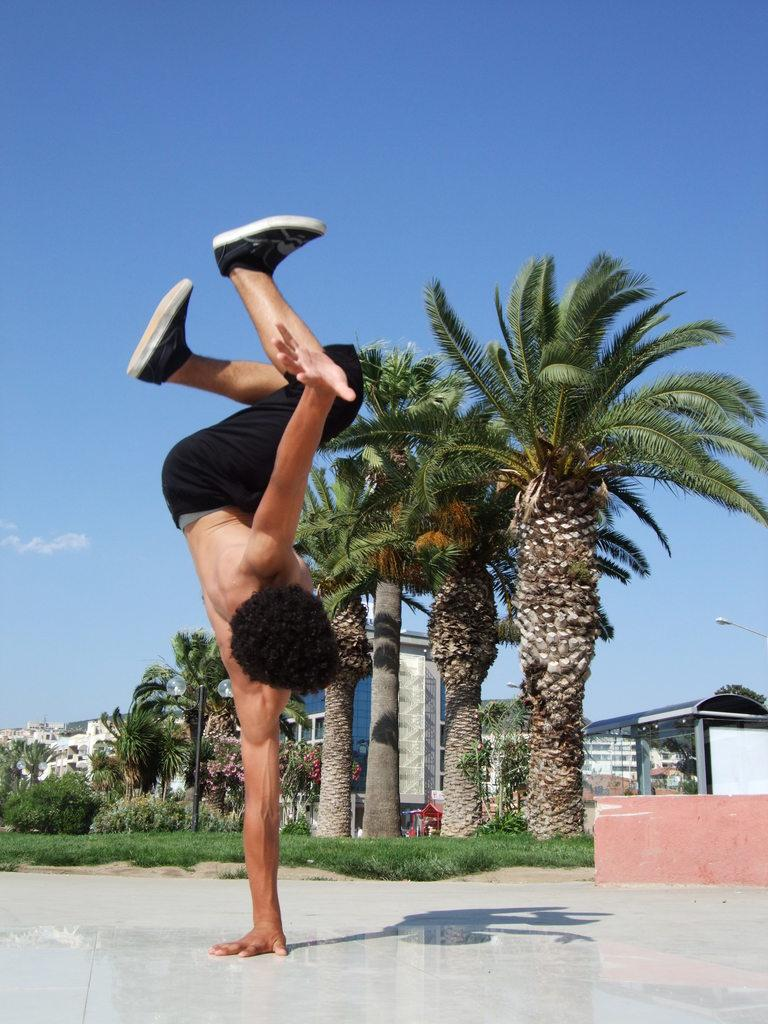What is the main subject of the picture? The main subject of the picture is a man. What type of clothing is the man wearing? The man is wearing trousers and shoes. What can be seen in the background of the picture? There are trees and buildings in the background of the picture. What is the condition of the sky in the picture? The sky is clear in the picture. What type of sack is the man carrying in the picture? There is no sack visible in the picture; the man is not carrying anything. What property does the man own in the picture? There is no information about the man's property in the picture. 